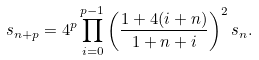Convert formula to latex. <formula><loc_0><loc_0><loc_500><loc_500>s _ { n + p } = 4 ^ { p } \prod _ { i = 0 } ^ { p - 1 } \left ( \frac { 1 + 4 ( i + n ) } { 1 + n + i } \right ) ^ { 2 } s _ { n } .</formula> 